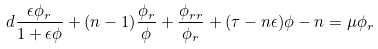<formula> <loc_0><loc_0><loc_500><loc_500>d \frac { \epsilon \phi _ { r } } { 1 + \epsilon \phi } + ( n - 1 ) \frac { \phi _ { r } } { \phi } + \frac { \phi _ { r r } } { \phi _ { r } } + ( \tau - n \epsilon ) \phi - n = \mu \phi _ { r }</formula> 